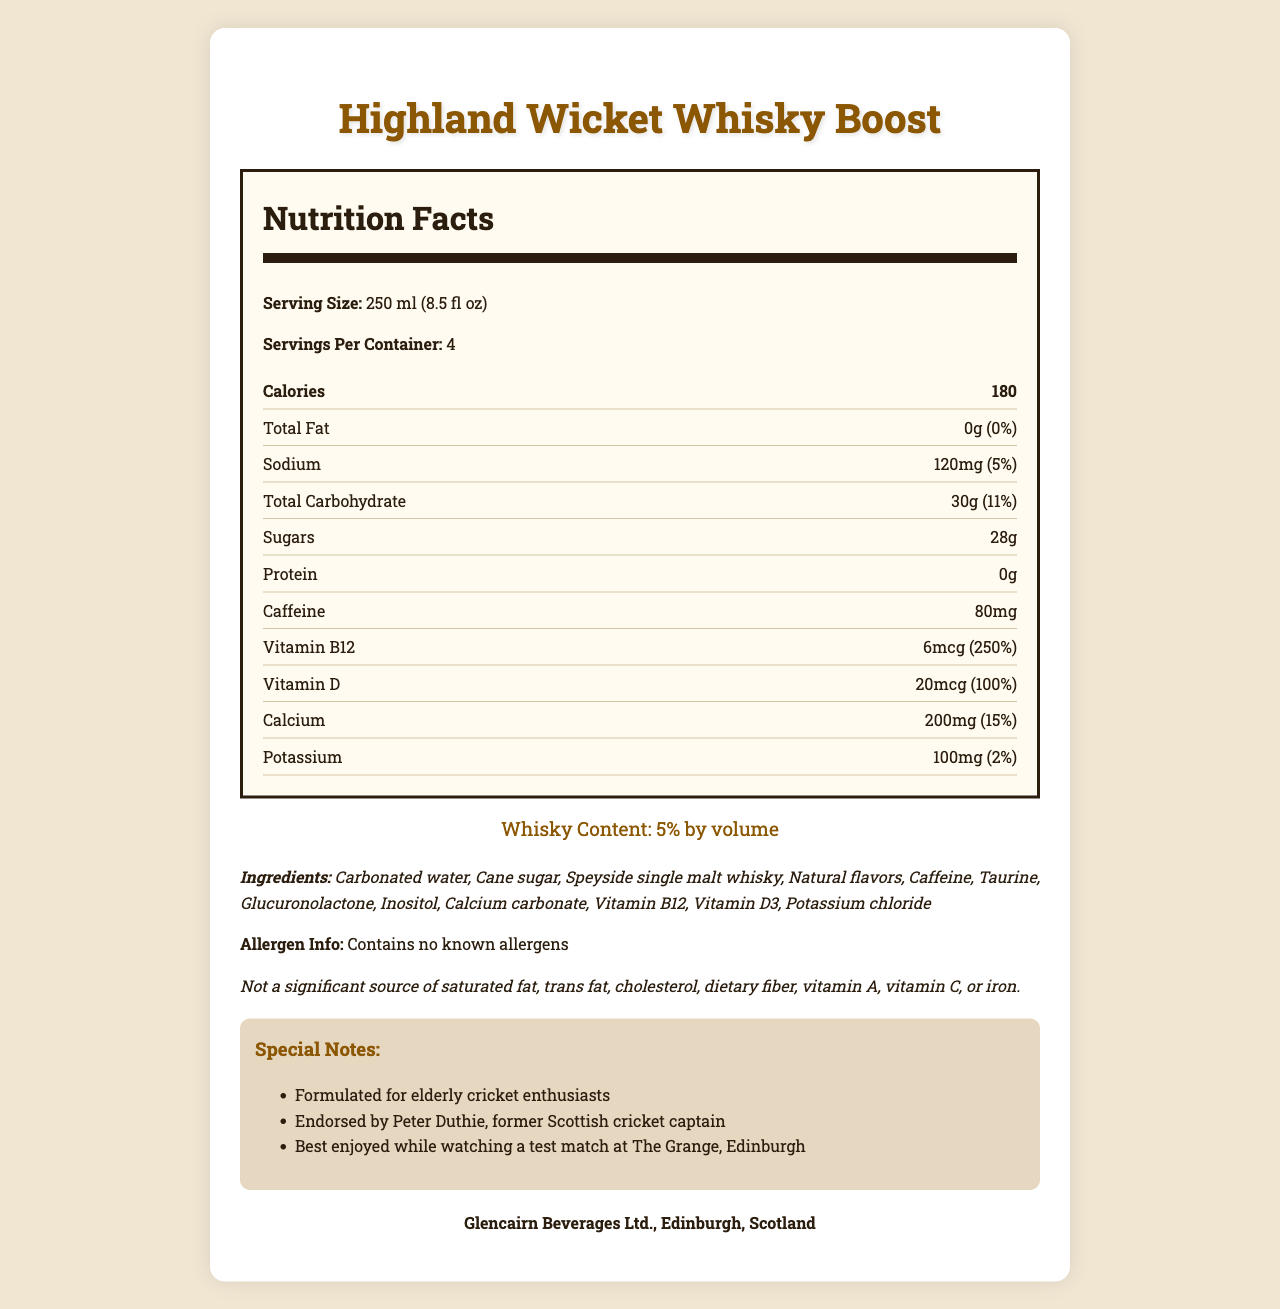What is the serving size of the Highland Wicket Whisky Boost? The serving size is mentioned at the beginning of the Nutrition Facts section.
Answer: 250 ml (8.5 fl oz) How many servings are there per container? The document states "Servings Per Container: 4" in the Nutrition Facts section.
Answer: 4 How much caffeine is in one serving of the drink? The amount of caffeine is listed in the Nutrition Facts under a specific item "Caffeine: 80mg".
Answer: 80mg What is the sodium content per serving and its daily value percentage? The sodium content is listed under the Nutrition Facts with the value "120mg (5%)".
Answer: 120mg, 5% Who endorses the Highland Wicket Whisky Boost? This information is provided under the Special Notes section.
Answer: Peter Duthie, former Scottish cricket captain Which of the following is a vitamin included in the drink? A. Vitamin A, B. Vitamin C, C. Vitamin D, D. Vitamin B6 The nutrition label lists Vitamin D and Vitamin B12, and none of the other options.
Answer: C What percentage of daily value does Vitamin B12 provide? The document states "Vitamin B12: 6mcg (250%)" in the Nutrition Facts section.
Answer: 250% True or False: The drink contains fiber. The disclaimer at the end of the document states that it is not a significant source of dietary fiber.
Answer: False Which of the following statements is true about the drink? I. Contains whisky, II. Contains allergens, III. Contains protein The drink contains whisky but no known allergens, and it has no protein.
Answer: I Summarize the main idea of the Highland Wicket Whisky Boost document. This summary captures the key elements such as the nutrition details, ingredients, target audience, and endorsement mentioned in the document.
Answer: The document provides the nutrition facts, serving size, ingredients, and special notes about Highland Wicket Whisky Boost, a whisky-infused energy drink formulated for elderly cricket enthusiasts and endorsed by Peter Duthie. What is the total carbohydrate content in one serving? The amount is listed directly under Total Carbohydrate in the Nutrition Facts section.
Answer: 30g (11%) Where is the Highland Wicket Whisky Boost manufactured? This detail is found at the end of the document under the manufacturer section.
Answer: Glencairn Beverages Ltd., Edinburgh, Scotland How much whisky does the drink contain by volume? This information is highlighted under the Whisky Content section in the document.
Answer: 5% by volume What is the source of fat in the drink? The document states "not a significant source of saturated fat, trans fat, cholesterol," and lists total fat as 0g, but the source is not specified and might not exist in the drink.
Answer: Cannot be determined 